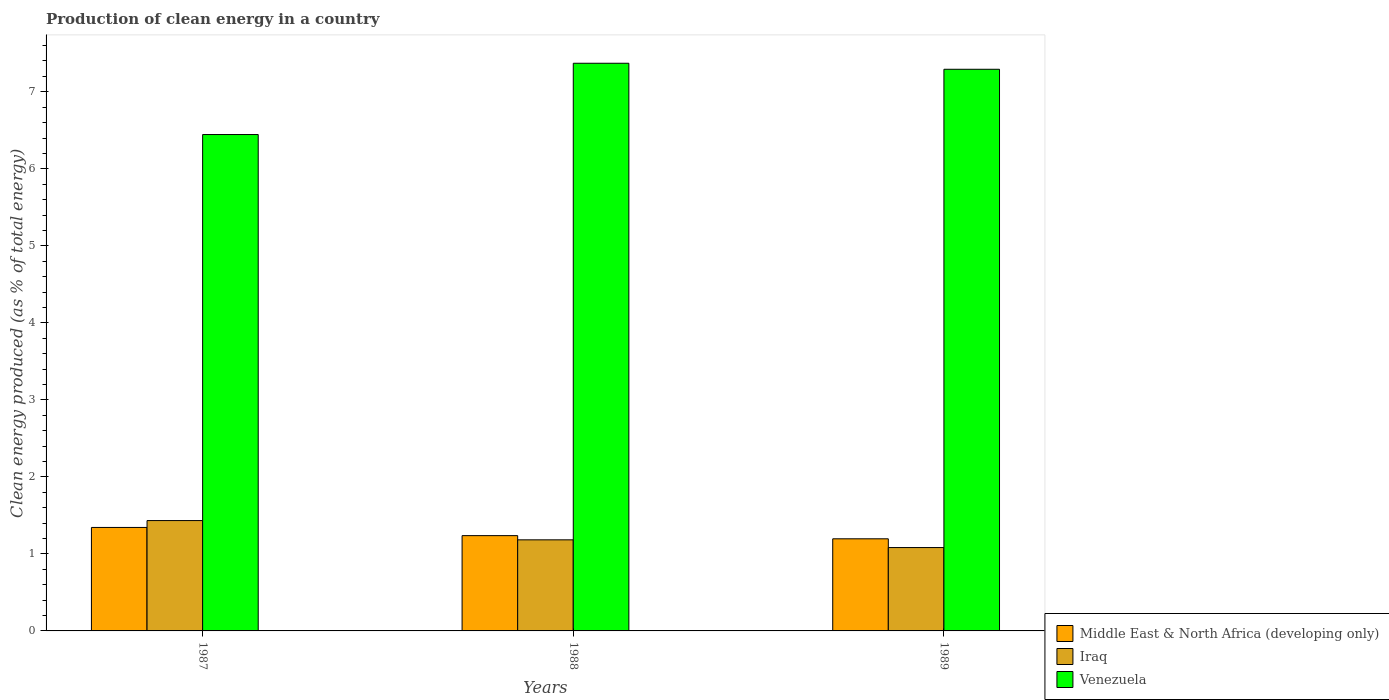How many groups of bars are there?
Provide a short and direct response. 3. Are the number of bars per tick equal to the number of legend labels?
Keep it short and to the point. Yes. Are the number of bars on each tick of the X-axis equal?
Provide a succinct answer. Yes. How many bars are there on the 2nd tick from the left?
Ensure brevity in your answer.  3. How many bars are there on the 2nd tick from the right?
Keep it short and to the point. 3. What is the label of the 2nd group of bars from the left?
Keep it short and to the point. 1988. In how many cases, is the number of bars for a given year not equal to the number of legend labels?
Provide a succinct answer. 0. What is the percentage of clean energy produced in Venezuela in 1987?
Your answer should be compact. 6.45. Across all years, what is the maximum percentage of clean energy produced in Iraq?
Offer a very short reply. 1.43. Across all years, what is the minimum percentage of clean energy produced in Iraq?
Ensure brevity in your answer.  1.08. In which year was the percentage of clean energy produced in Iraq minimum?
Provide a succinct answer. 1989. What is the total percentage of clean energy produced in Iraq in the graph?
Your answer should be very brief. 3.7. What is the difference between the percentage of clean energy produced in Venezuela in 1987 and that in 1988?
Your answer should be compact. -0.93. What is the difference between the percentage of clean energy produced in Middle East & North Africa (developing only) in 1988 and the percentage of clean energy produced in Venezuela in 1989?
Your response must be concise. -6.06. What is the average percentage of clean energy produced in Venezuela per year?
Make the answer very short. 7.04. In the year 1989, what is the difference between the percentage of clean energy produced in Iraq and percentage of clean energy produced in Middle East & North Africa (developing only)?
Offer a very short reply. -0.11. What is the ratio of the percentage of clean energy produced in Venezuela in 1987 to that in 1989?
Your answer should be compact. 0.88. What is the difference between the highest and the second highest percentage of clean energy produced in Middle East & North Africa (developing only)?
Provide a short and direct response. 0.11. What is the difference between the highest and the lowest percentage of clean energy produced in Iraq?
Offer a very short reply. 0.35. In how many years, is the percentage of clean energy produced in Venezuela greater than the average percentage of clean energy produced in Venezuela taken over all years?
Your answer should be compact. 2. Is the sum of the percentage of clean energy produced in Venezuela in 1987 and 1988 greater than the maximum percentage of clean energy produced in Iraq across all years?
Give a very brief answer. Yes. What does the 1st bar from the left in 1989 represents?
Offer a very short reply. Middle East & North Africa (developing only). What does the 3rd bar from the right in 1988 represents?
Give a very brief answer. Middle East & North Africa (developing only). Are all the bars in the graph horizontal?
Provide a succinct answer. No. What is the difference between two consecutive major ticks on the Y-axis?
Offer a very short reply. 1. Are the values on the major ticks of Y-axis written in scientific E-notation?
Provide a short and direct response. No. Does the graph contain grids?
Make the answer very short. No. How are the legend labels stacked?
Offer a very short reply. Vertical. What is the title of the graph?
Offer a terse response. Production of clean energy in a country. What is the label or title of the Y-axis?
Your response must be concise. Clean energy produced (as % of total energy). What is the Clean energy produced (as % of total energy) in Middle East & North Africa (developing only) in 1987?
Keep it short and to the point. 1.34. What is the Clean energy produced (as % of total energy) in Iraq in 1987?
Make the answer very short. 1.43. What is the Clean energy produced (as % of total energy) of Venezuela in 1987?
Keep it short and to the point. 6.45. What is the Clean energy produced (as % of total energy) in Middle East & North Africa (developing only) in 1988?
Offer a terse response. 1.24. What is the Clean energy produced (as % of total energy) in Iraq in 1988?
Make the answer very short. 1.18. What is the Clean energy produced (as % of total energy) in Venezuela in 1988?
Ensure brevity in your answer.  7.37. What is the Clean energy produced (as % of total energy) of Middle East & North Africa (developing only) in 1989?
Make the answer very short. 1.2. What is the Clean energy produced (as % of total energy) of Iraq in 1989?
Provide a short and direct response. 1.08. What is the Clean energy produced (as % of total energy) in Venezuela in 1989?
Your answer should be compact. 7.29. Across all years, what is the maximum Clean energy produced (as % of total energy) in Middle East & North Africa (developing only)?
Provide a short and direct response. 1.34. Across all years, what is the maximum Clean energy produced (as % of total energy) of Iraq?
Your answer should be compact. 1.43. Across all years, what is the maximum Clean energy produced (as % of total energy) in Venezuela?
Provide a short and direct response. 7.37. Across all years, what is the minimum Clean energy produced (as % of total energy) in Middle East & North Africa (developing only)?
Offer a terse response. 1.2. Across all years, what is the minimum Clean energy produced (as % of total energy) of Iraq?
Offer a terse response. 1.08. Across all years, what is the minimum Clean energy produced (as % of total energy) in Venezuela?
Your answer should be compact. 6.45. What is the total Clean energy produced (as % of total energy) of Middle East & North Africa (developing only) in the graph?
Ensure brevity in your answer.  3.78. What is the total Clean energy produced (as % of total energy) in Iraq in the graph?
Provide a succinct answer. 3.7. What is the total Clean energy produced (as % of total energy) in Venezuela in the graph?
Offer a terse response. 21.11. What is the difference between the Clean energy produced (as % of total energy) in Middle East & North Africa (developing only) in 1987 and that in 1988?
Keep it short and to the point. 0.11. What is the difference between the Clean energy produced (as % of total energy) of Iraq in 1987 and that in 1988?
Your answer should be compact. 0.25. What is the difference between the Clean energy produced (as % of total energy) of Venezuela in 1987 and that in 1988?
Offer a very short reply. -0.93. What is the difference between the Clean energy produced (as % of total energy) of Middle East & North Africa (developing only) in 1987 and that in 1989?
Make the answer very short. 0.15. What is the difference between the Clean energy produced (as % of total energy) of Iraq in 1987 and that in 1989?
Make the answer very short. 0.35. What is the difference between the Clean energy produced (as % of total energy) in Venezuela in 1987 and that in 1989?
Give a very brief answer. -0.85. What is the difference between the Clean energy produced (as % of total energy) in Middle East & North Africa (developing only) in 1988 and that in 1989?
Keep it short and to the point. 0.04. What is the difference between the Clean energy produced (as % of total energy) in Iraq in 1988 and that in 1989?
Offer a very short reply. 0.1. What is the difference between the Clean energy produced (as % of total energy) of Venezuela in 1988 and that in 1989?
Ensure brevity in your answer.  0.08. What is the difference between the Clean energy produced (as % of total energy) of Middle East & North Africa (developing only) in 1987 and the Clean energy produced (as % of total energy) of Iraq in 1988?
Your answer should be compact. 0.16. What is the difference between the Clean energy produced (as % of total energy) in Middle East & North Africa (developing only) in 1987 and the Clean energy produced (as % of total energy) in Venezuela in 1988?
Your answer should be very brief. -6.03. What is the difference between the Clean energy produced (as % of total energy) in Iraq in 1987 and the Clean energy produced (as % of total energy) in Venezuela in 1988?
Keep it short and to the point. -5.94. What is the difference between the Clean energy produced (as % of total energy) in Middle East & North Africa (developing only) in 1987 and the Clean energy produced (as % of total energy) in Iraq in 1989?
Provide a short and direct response. 0.26. What is the difference between the Clean energy produced (as % of total energy) in Middle East & North Africa (developing only) in 1987 and the Clean energy produced (as % of total energy) in Venezuela in 1989?
Provide a short and direct response. -5.95. What is the difference between the Clean energy produced (as % of total energy) in Iraq in 1987 and the Clean energy produced (as % of total energy) in Venezuela in 1989?
Offer a very short reply. -5.86. What is the difference between the Clean energy produced (as % of total energy) of Middle East & North Africa (developing only) in 1988 and the Clean energy produced (as % of total energy) of Iraq in 1989?
Keep it short and to the point. 0.15. What is the difference between the Clean energy produced (as % of total energy) of Middle East & North Africa (developing only) in 1988 and the Clean energy produced (as % of total energy) of Venezuela in 1989?
Provide a short and direct response. -6.06. What is the difference between the Clean energy produced (as % of total energy) of Iraq in 1988 and the Clean energy produced (as % of total energy) of Venezuela in 1989?
Your answer should be compact. -6.11. What is the average Clean energy produced (as % of total energy) of Middle East & North Africa (developing only) per year?
Offer a very short reply. 1.26. What is the average Clean energy produced (as % of total energy) in Iraq per year?
Offer a very short reply. 1.23. What is the average Clean energy produced (as % of total energy) of Venezuela per year?
Ensure brevity in your answer.  7.04. In the year 1987, what is the difference between the Clean energy produced (as % of total energy) of Middle East & North Africa (developing only) and Clean energy produced (as % of total energy) of Iraq?
Provide a short and direct response. -0.09. In the year 1987, what is the difference between the Clean energy produced (as % of total energy) in Middle East & North Africa (developing only) and Clean energy produced (as % of total energy) in Venezuela?
Your response must be concise. -5.1. In the year 1987, what is the difference between the Clean energy produced (as % of total energy) in Iraq and Clean energy produced (as % of total energy) in Venezuela?
Ensure brevity in your answer.  -5.01. In the year 1988, what is the difference between the Clean energy produced (as % of total energy) in Middle East & North Africa (developing only) and Clean energy produced (as % of total energy) in Iraq?
Offer a terse response. 0.05. In the year 1988, what is the difference between the Clean energy produced (as % of total energy) of Middle East & North Africa (developing only) and Clean energy produced (as % of total energy) of Venezuela?
Keep it short and to the point. -6.13. In the year 1988, what is the difference between the Clean energy produced (as % of total energy) of Iraq and Clean energy produced (as % of total energy) of Venezuela?
Your answer should be compact. -6.19. In the year 1989, what is the difference between the Clean energy produced (as % of total energy) of Middle East & North Africa (developing only) and Clean energy produced (as % of total energy) of Iraq?
Your response must be concise. 0.11. In the year 1989, what is the difference between the Clean energy produced (as % of total energy) of Middle East & North Africa (developing only) and Clean energy produced (as % of total energy) of Venezuela?
Provide a short and direct response. -6.1. In the year 1989, what is the difference between the Clean energy produced (as % of total energy) of Iraq and Clean energy produced (as % of total energy) of Venezuela?
Your answer should be compact. -6.21. What is the ratio of the Clean energy produced (as % of total energy) of Middle East & North Africa (developing only) in 1987 to that in 1988?
Make the answer very short. 1.09. What is the ratio of the Clean energy produced (as % of total energy) of Iraq in 1987 to that in 1988?
Provide a short and direct response. 1.21. What is the ratio of the Clean energy produced (as % of total energy) of Venezuela in 1987 to that in 1988?
Provide a succinct answer. 0.87. What is the ratio of the Clean energy produced (as % of total energy) in Middle East & North Africa (developing only) in 1987 to that in 1989?
Make the answer very short. 1.12. What is the ratio of the Clean energy produced (as % of total energy) of Iraq in 1987 to that in 1989?
Give a very brief answer. 1.32. What is the ratio of the Clean energy produced (as % of total energy) of Venezuela in 1987 to that in 1989?
Offer a very short reply. 0.88. What is the ratio of the Clean energy produced (as % of total energy) in Middle East & North Africa (developing only) in 1988 to that in 1989?
Provide a succinct answer. 1.03. What is the ratio of the Clean energy produced (as % of total energy) in Iraq in 1988 to that in 1989?
Ensure brevity in your answer.  1.09. What is the ratio of the Clean energy produced (as % of total energy) in Venezuela in 1988 to that in 1989?
Your answer should be very brief. 1.01. What is the difference between the highest and the second highest Clean energy produced (as % of total energy) of Middle East & North Africa (developing only)?
Offer a very short reply. 0.11. What is the difference between the highest and the second highest Clean energy produced (as % of total energy) of Iraq?
Ensure brevity in your answer.  0.25. What is the difference between the highest and the second highest Clean energy produced (as % of total energy) in Venezuela?
Make the answer very short. 0.08. What is the difference between the highest and the lowest Clean energy produced (as % of total energy) of Middle East & North Africa (developing only)?
Make the answer very short. 0.15. What is the difference between the highest and the lowest Clean energy produced (as % of total energy) of Iraq?
Keep it short and to the point. 0.35. What is the difference between the highest and the lowest Clean energy produced (as % of total energy) in Venezuela?
Offer a terse response. 0.93. 